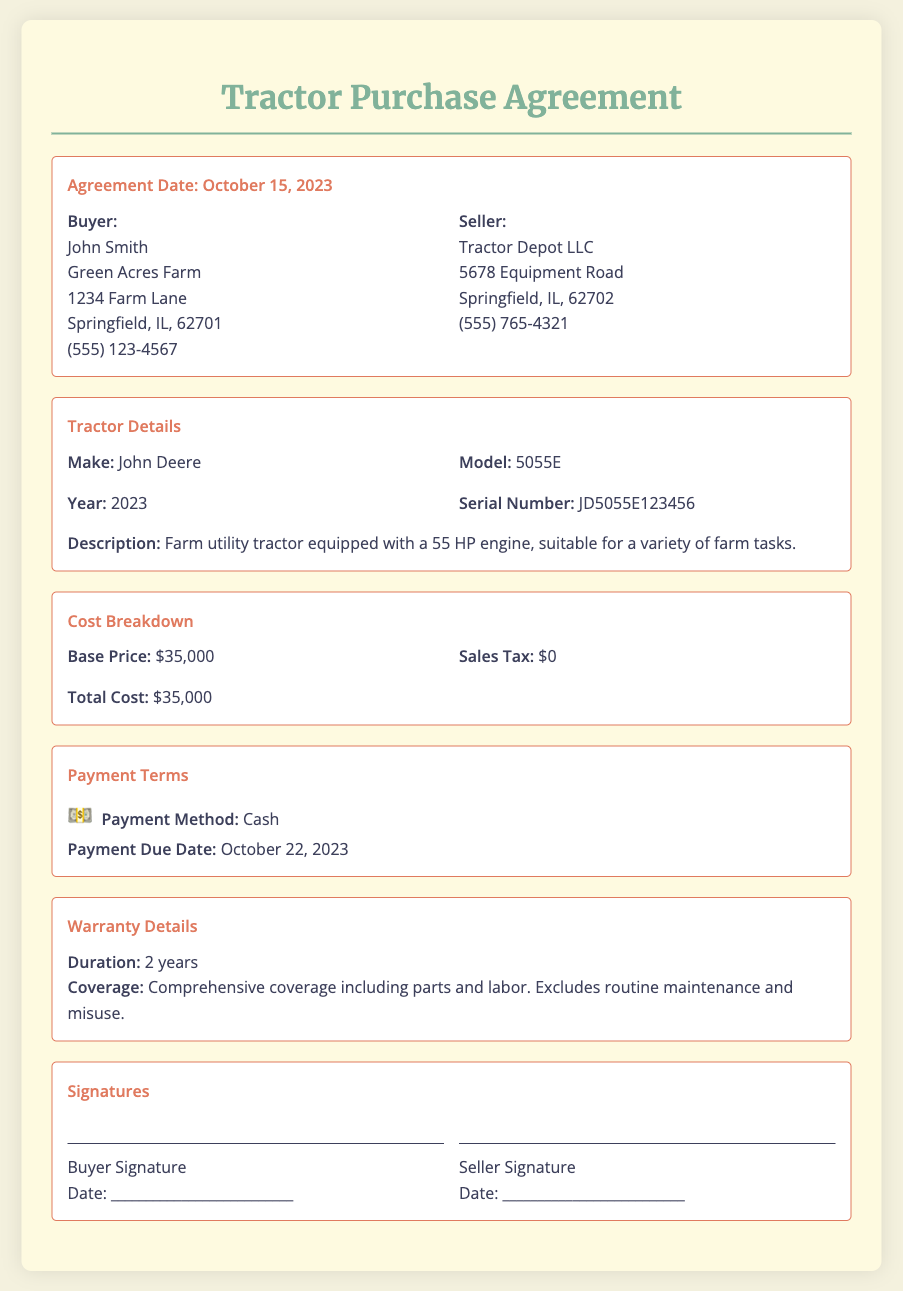What is the agreement date? The agreement date is stated clearly in the document, which is October 15, 2023.
Answer: October 15, 2023 Who is the buyer? The buyer's details are listed, including the name, John Smith, and his farm's name.
Answer: John Smith What is the model of the tractor? The document specifies the model of the tractor under the Tractor Details section, which is 5055E.
Answer: 5055E What is the total cost? The total cost combines the base price and sales tax, which is presented in the cost breakdown section.
Answer: $35,000 What payment method is used? The payment method is explicitly indicated in the Payment Terms section of the document.
Answer: Cash How long is the warranty coverage? The warranty duration is mentioned in the Warranty Details section, specifying the time period of coverage.
Answer: 2 years What is the due date for payment? The payment due date is clearly stated in the Payment Terms section.
Answer: October 22, 2023 What is excluded from warranty coverage? The document mentions exclusions to the warranty, which specifically includes routine maintenance and misuse.
Answer: Routine maintenance and misuse What is the seller's name? The seller's information is presented in the document, including the name of the company selling the tractor.
Answer: Tractor Depot LLC 